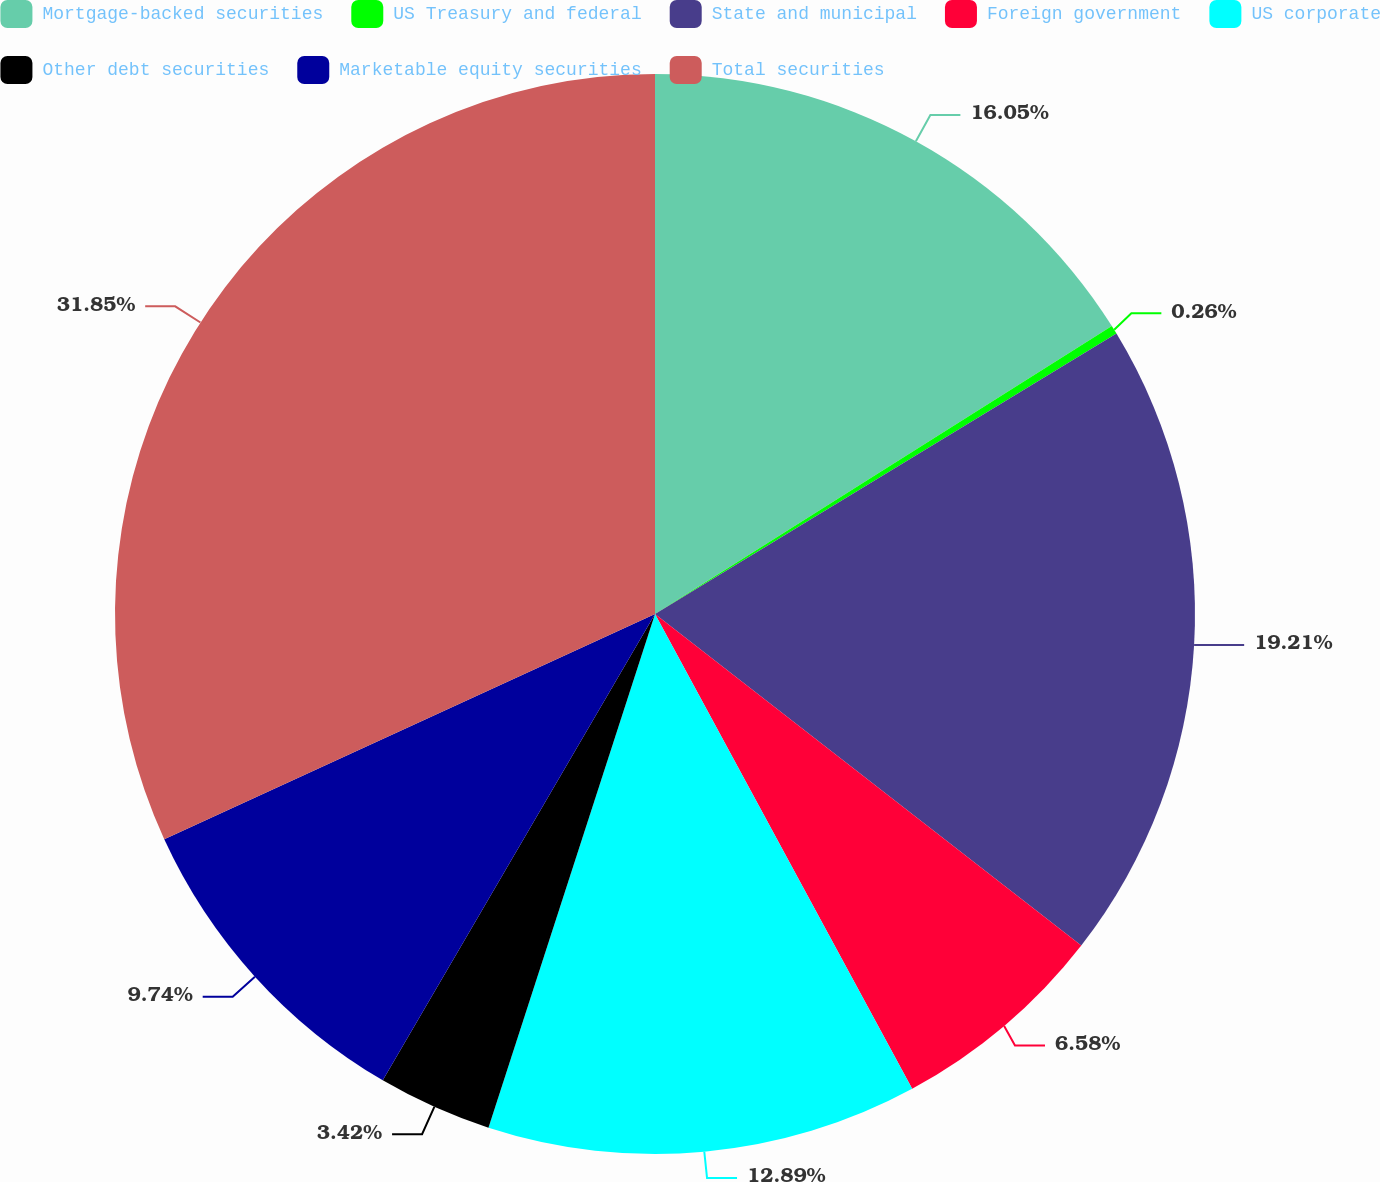<chart> <loc_0><loc_0><loc_500><loc_500><pie_chart><fcel>Mortgage-backed securities<fcel>US Treasury and federal<fcel>State and municipal<fcel>Foreign government<fcel>US corporate<fcel>Other debt securities<fcel>Marketable equity securities<fcel>Total securities<nl><fcel>16.05%<fcel>0.26%<fcel>19.21%<fcel>6.58%<fcel>12.89%<fcel>3.42%<fcel>9.74%<fcel>31.85%<nl></chart> 